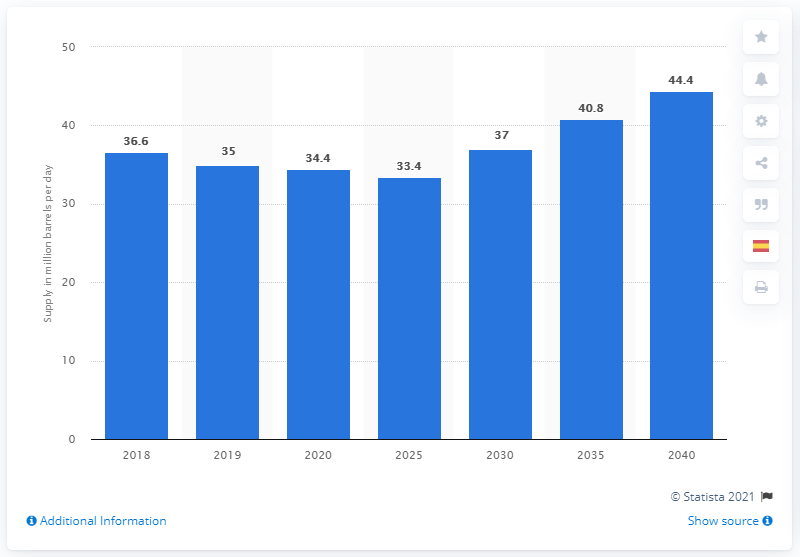Indicate a few pertinent items in this graphic. According to projections, the daily supply of oil from OPEC member states is expected to reach 44.4 by 2040. 